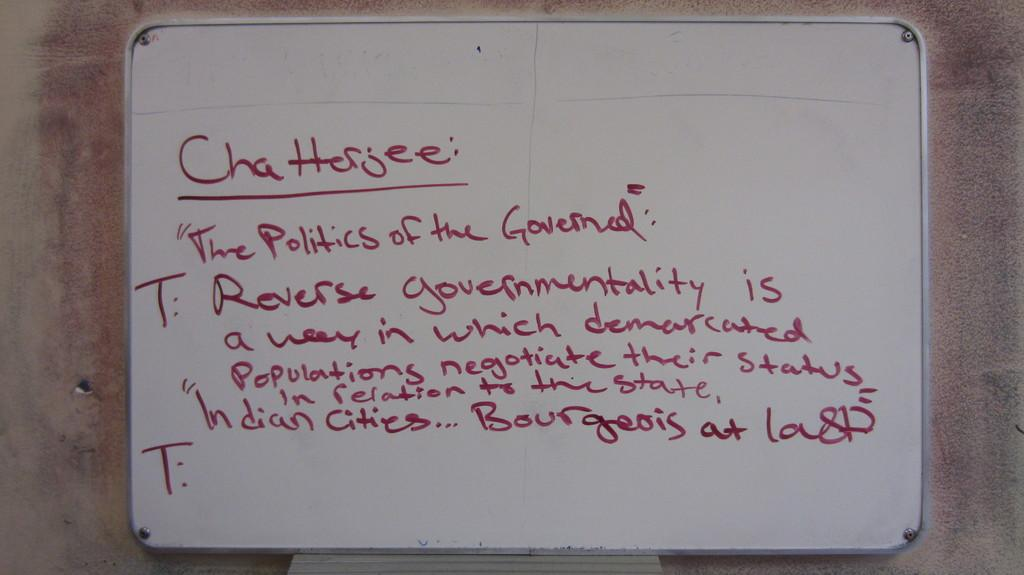<image>
Create a compact narrative representing the image presented. White board which says "Chatterjee" in red letters. 